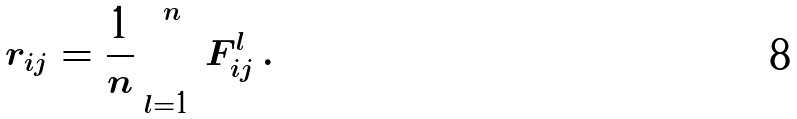Convert formula to latex. <formula><loc_0><loc_0><loc_500><loc_500>r _ { i j } = \frac { 1 } { n } \sum _ { l = 1 } ^ { n } F _ { i j } ^ { l } \, .</formula> 